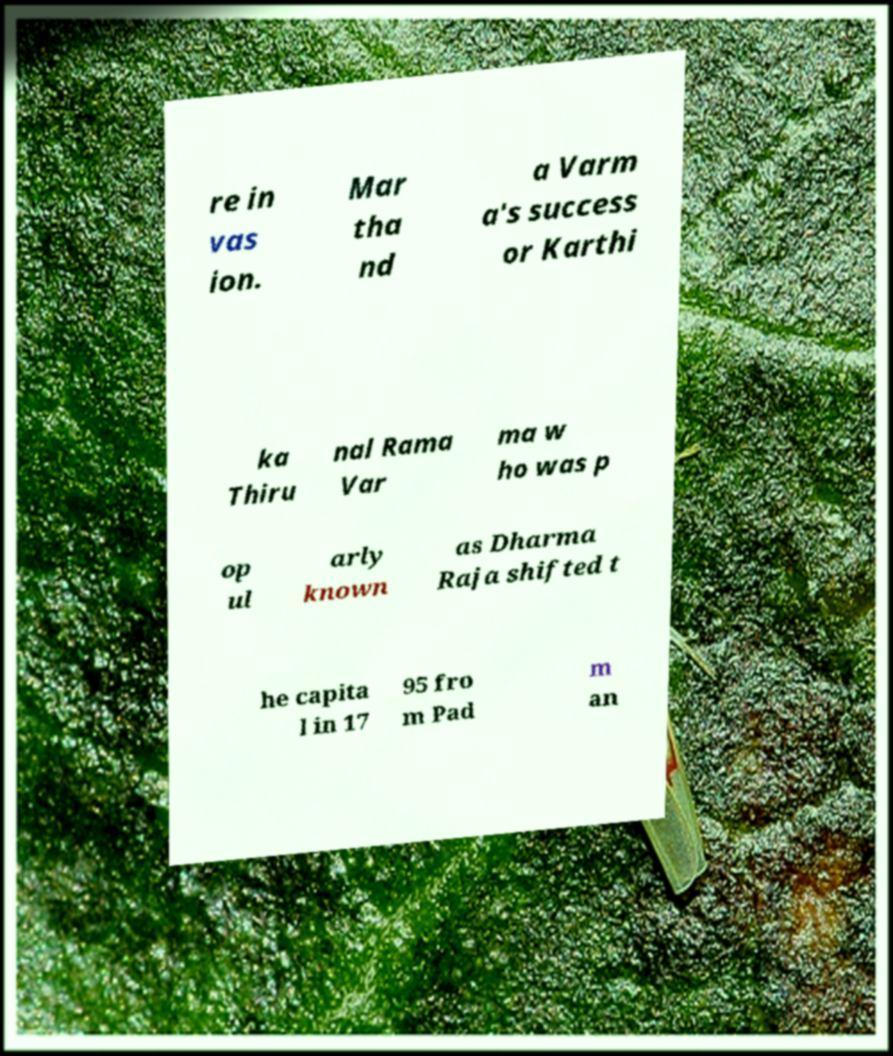Can you accurately transcribe the text from the provided image for me? re in vas ion. Mar tha nd a Varm a's success or Karthi ka Thiru nal Rama Var ma w ho was p op ul arly known as Dharma Raja shifted t he capita l in 17 95 fro m Pad m an 